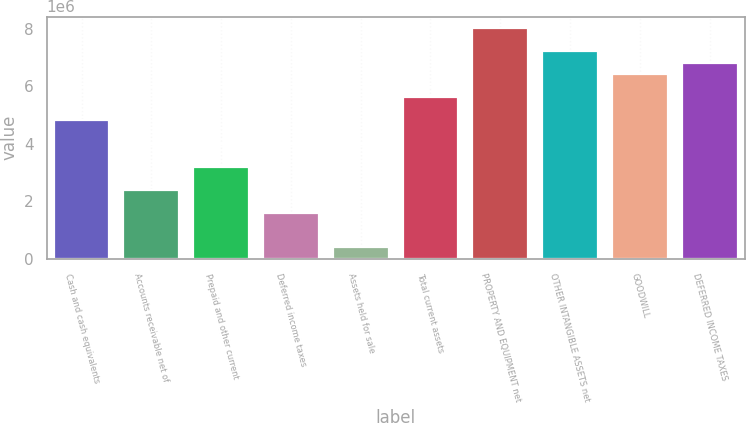Convert chart. <chart><loc_0><loc_0><loc_500><loc_500><bar_chart><fcel>Cash and cash equivalents<fcel>Accounts receivable net of<fcel>Prepaid and other current<fcel>Deferred income taxes<fcel>Assets held for sale<fcel>Total current assets<fcel>PROPERTY AND EQUIPMENT net<fcel>OTHER INTANGIBLE ASSETS net<fcel>GOODWILL<fcel>DEFERRED INCOME TAXES<nl><fcel>4.81445e+06<fcel>2.40837e+06<fcel>3.2104e+06<fcel>1.60635e+06<fcel>403310<fcel>5.61648e+06<fcel>8.02255e+06<fcel>7.22053e+06<fcel>6.4185e+06<fcel>6.81951e+06<nl></chart> 